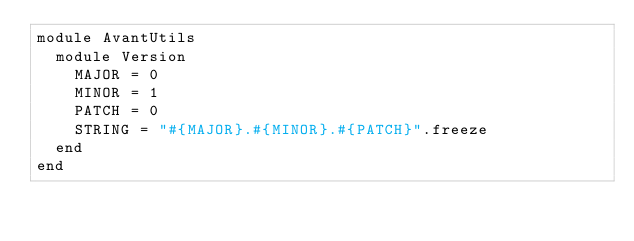Convert code to text. <code><loc_0><loc_0><loc_500><loc_500><_Ruby_>module AvantUtils
  module Version
    MAJOR = 0
    MINOR = 1
    PATCH = 0
    STRING = "#{MAJOR}.#{MINOR}.#{PATCH}".freeze
  end
end
</code> 